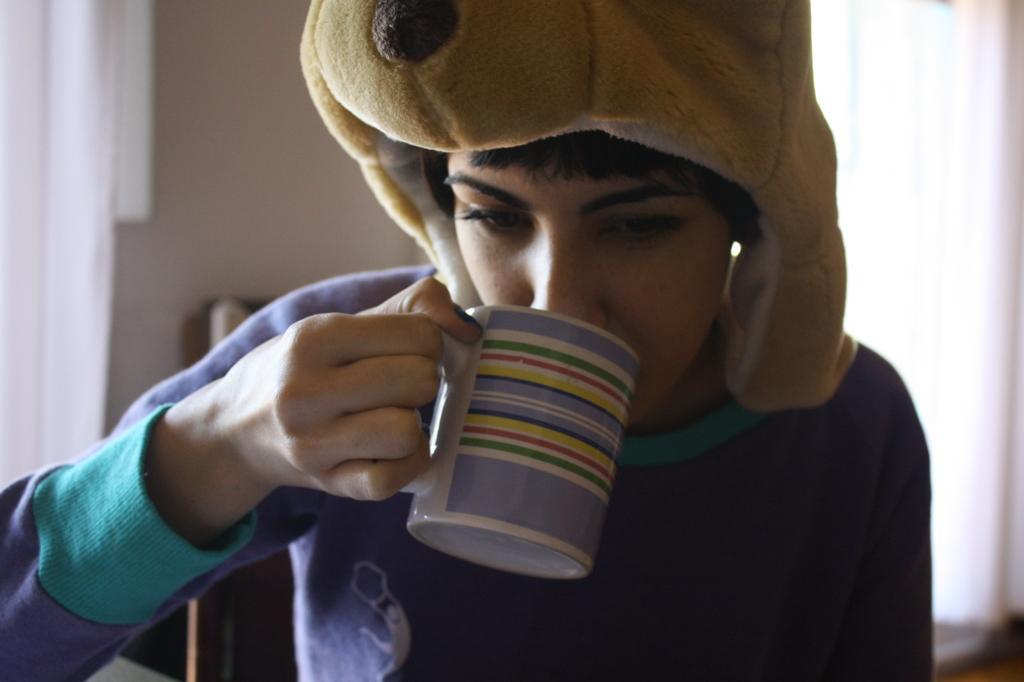Can you describe this image briefly? In the middle of the image a person is sitting and holding a cup. Behind the person we can see a wall and curtain. 